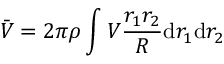<formula> <loc_0><loc_0><loc_500><loc_500>\bar { V } = 2 \pi \rho \int V \frac { r _ { 1 } r _ { 2 } } { R } d r _ { 1 } d r _ { 2 }</formula> 